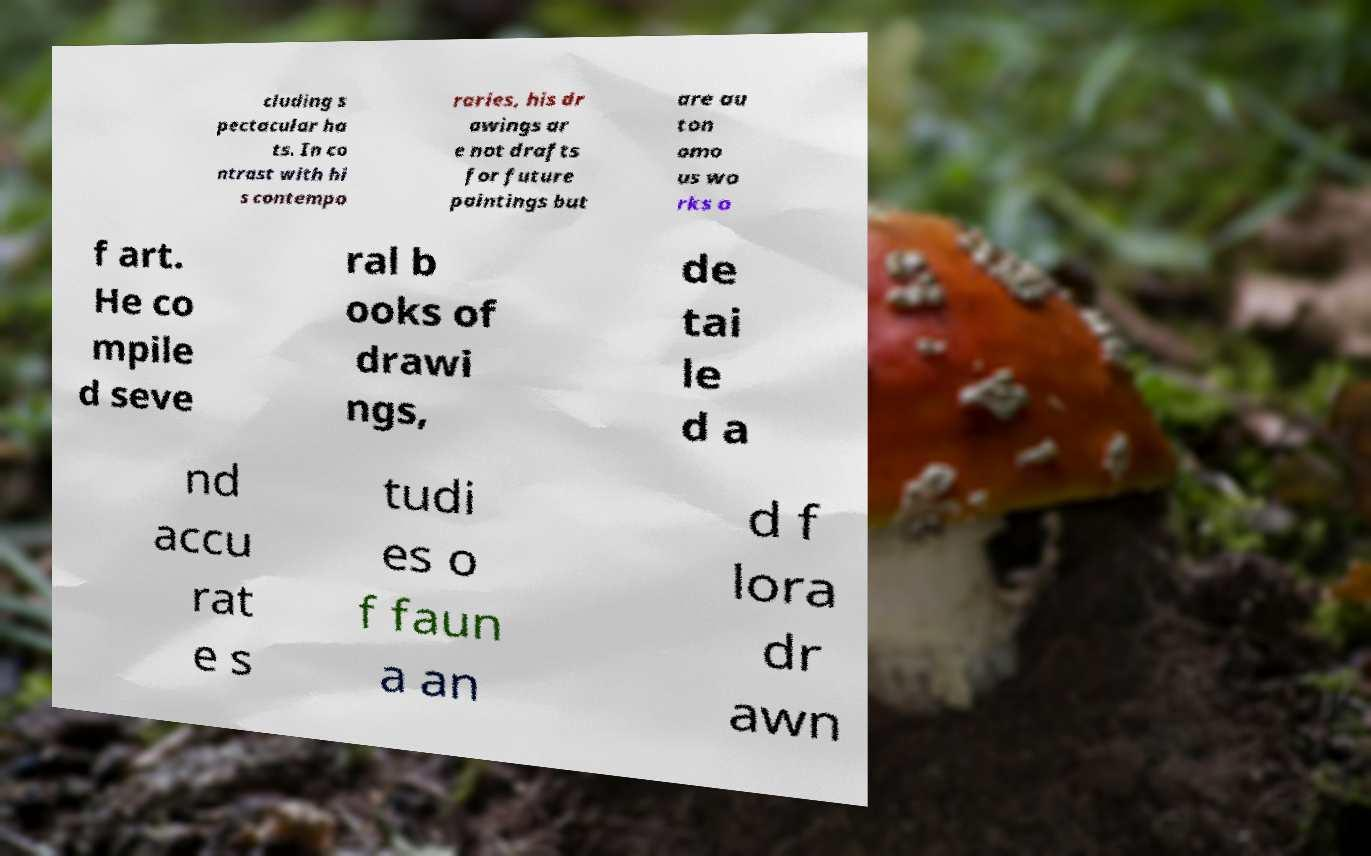What messages or text are displayed in this image? I need them in a readable, typed format. cluding s pectacular ha ts. In co ntrast with hi s contempo raries, his dr awings ar e not drafts for future paintings but are au ton omo us wo rks o f art. He co mpile d seve ral b ooks of drawi ngs, de tai le d a nd accu rat e s tudi es o f faun a an d f lora dr awn 